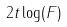<formula> <loc_0><loc_0><loc_500><loc_500>2 t \log ( F )</formula> 